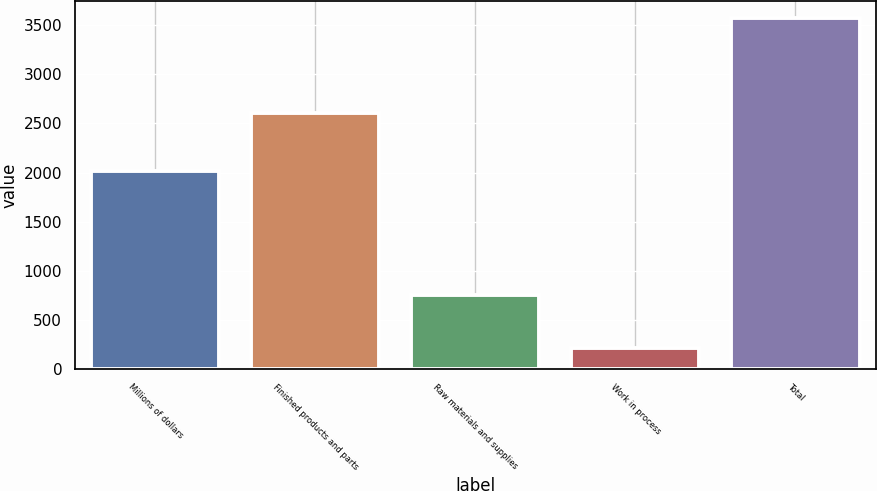Convert chart to OTSL. <chart><loc_0><loc_0><loc_500><loc_500><bar_chart><fcel>Millions of dollars<fcel>Finished products and parts<fcel>Raw materials and supplies<fcel>Work in process<fcel>Total<nl><fcel>2014<fcel>2606<fcel>754<fcel>211<fcel>3571<nl></chart> 